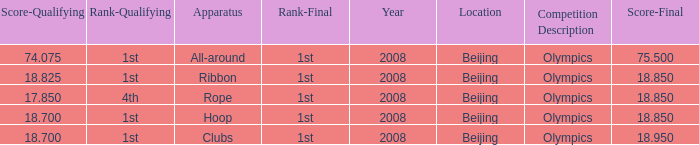On which apparatus did Kanayeva have a final score smaller than 75.5 and a qualifying score smaller than 18.7? Rope. 